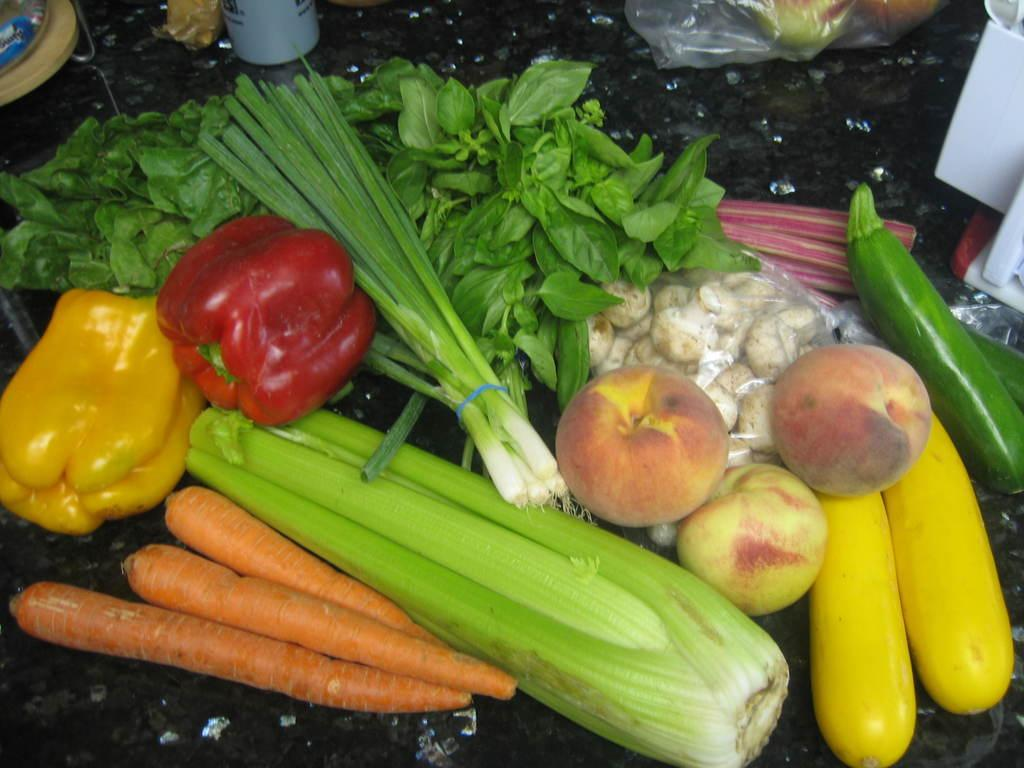What type of surface is present in the image? There is a table in the image. What types of food items can be seen on the table? Bell peppers, leafy vegetables, mushrooms, apples, zucchini, corn, and carrots are visible in the image. Is there any covering on the table? Yes, there is a cover on the table. Are there any other objects on the table besides the food items? Yes, there are other objects placed on the table. Can you see a plane flying over the field in the image? There is no plane or field present in the image; it features a table with various food items and other objects. 